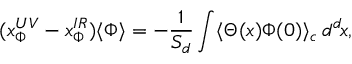Convert formula to latex. <formula><loc_0><loc_0><loc_500><loc_500>( x _ { \Phi } ^ { U V } - x _ { \Phi } ^ { I R } ) \langle \Phi \rangle = - { \frac { 1 } { S _ { d } } } \int \langle \Theta ( x ) \Phi ( 0 ) \rangle _ { c } \, d ^ { d } \, x ,</formula> 